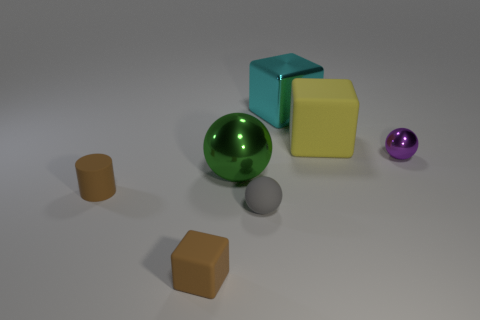What materials do these objects in the image appear to be made of? The objects present a variety of textures that suggest different materials. The cubes and spheres look like they could be made of polished metal or plastic, which gives them a reflective surface, while the matte cubes seem to be made of a non-reflective material like possibly frosted glass or a matte-finished plastic. 